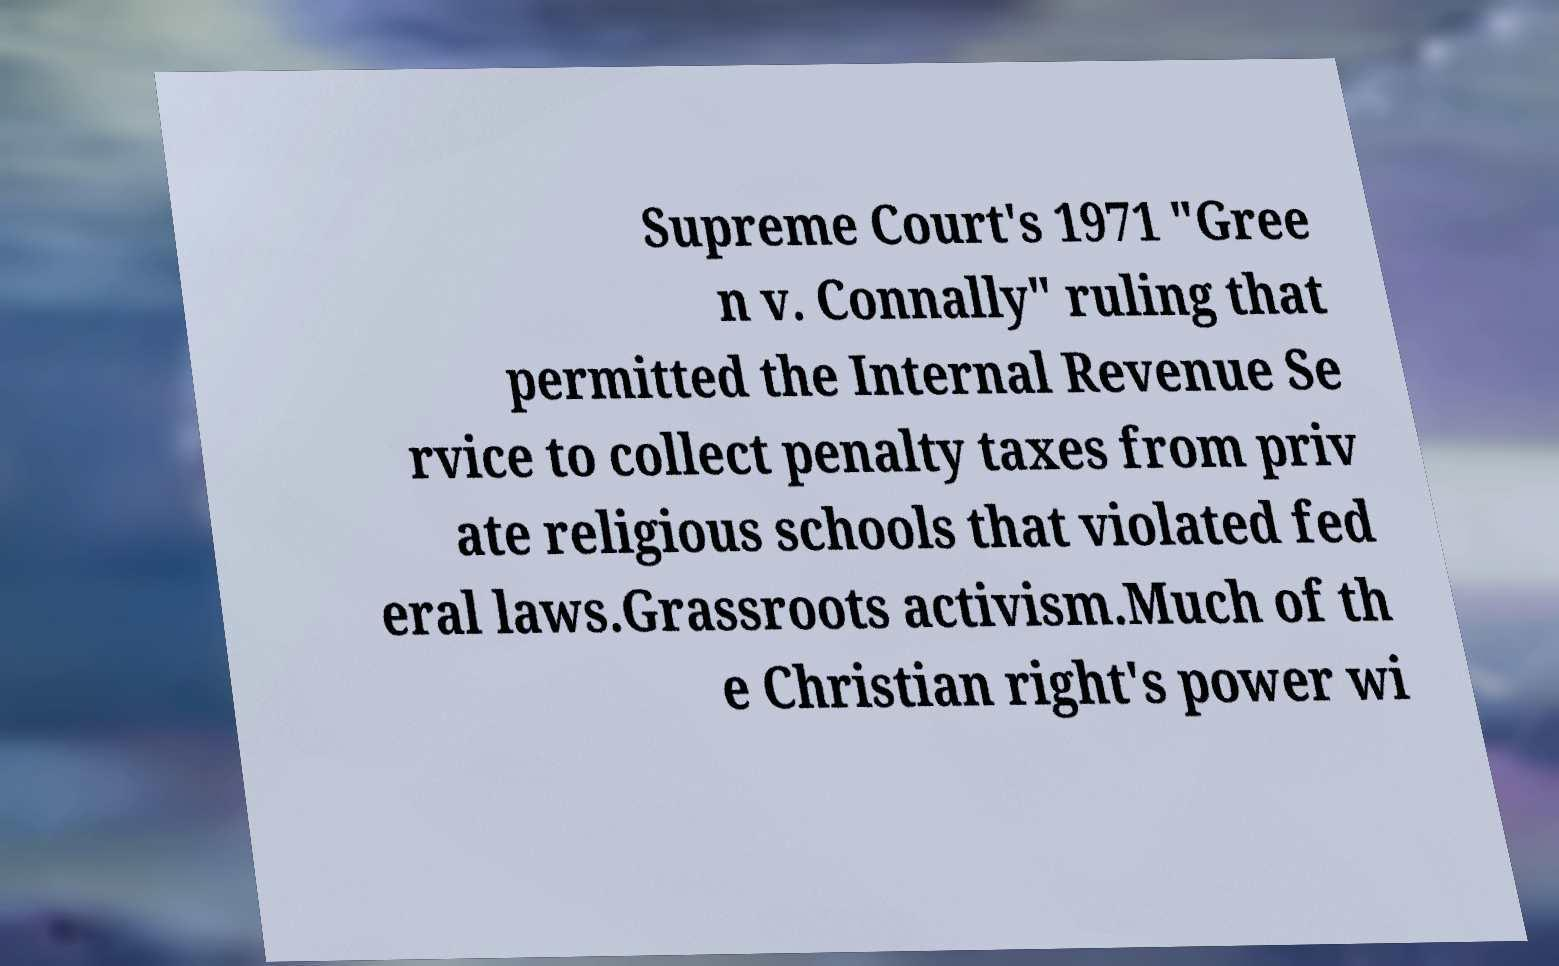Could you assist in decoding the text presented in this image and type it out clearly? Supreme Court's 1971 "Gree n v. Connally" ruling that permitted the Internal Revenue Se rvice to collect penalty taxes from priv ate religious schools that violated fed eral laws.Grassroots activism.Much of th e Christian right's power wi 